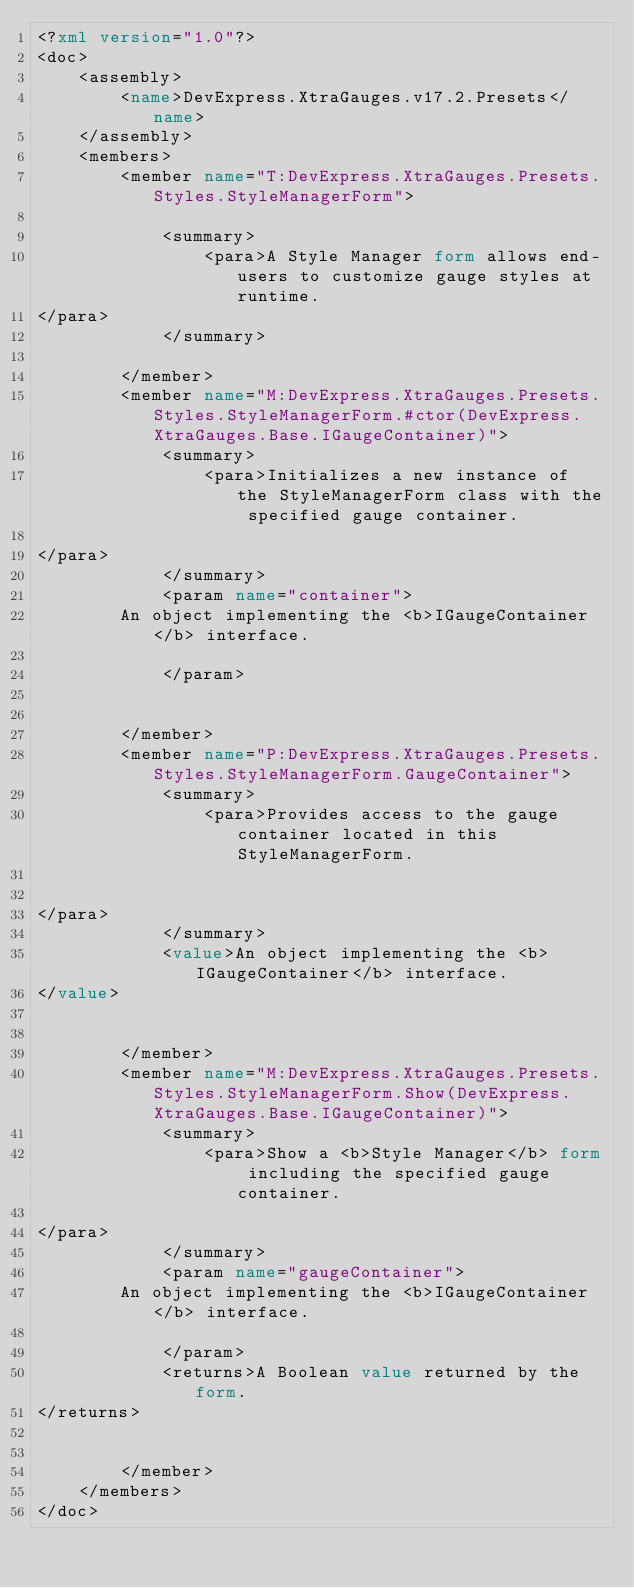<code> <loc_0><loc_0><loc_500><loc_500><_XML_><?xml version="1.0"?>
<doc>
    <assembly>
        <name>DevExpress.XtraGauges.v17.2.Presets</name>
    </assembly>
    <members>
        <member name="T:DevExpress.XtraGauges.Presets.Styles.StyleManagerForm">

            <summary>
                <para>A Style Manager form allows end-users to customize gauge styles at runtime. 
</para>
            </summary>

        </member>
        <member name="M:DevExpress.XtraGauges.Presets.Styles.StyleManagerForm.#ctor(DevExpress.XtraGauges.Base.IGaugeContainer)">
            <summary>
                <para>Initializes a new instance of the StyleManagerForm class with the specified gauge container.

</para>
            </summary>
            <param name="container">
		An object implementing the <b>IGaugeContainer</b> interface.

            </param>


        </member>
        <member name="P:DevExpress.XtraGauges.Presets.Styles.StyleManagerForm.GaugeContainer">
            <summary>
                <para>Provides access to the gauge container located in this StyleManagerForm.


</para>
            </summary>
            <value>An object implementing the <b>IGaugeContainer</b> interface.
</value>


        </member>
        <member name="M:DevExpress.XtraGauges.Presets.Styles.StyleManagerForm.Show(DevExpress.XtraGauges.Base.IGaugeContainer)">
            <summary>
                <para>Show a <b>Style Manager</b> form including the specified gauge container.

</para>
            </summary>
            <param name="gaugeContainer">
		An object implementing the <b>IGaugeContainer</b> interface.

            </param>
            <returns>A Boolean value returned by the form.
</returns>


        </member>
    </members>
</doc>
</code> 